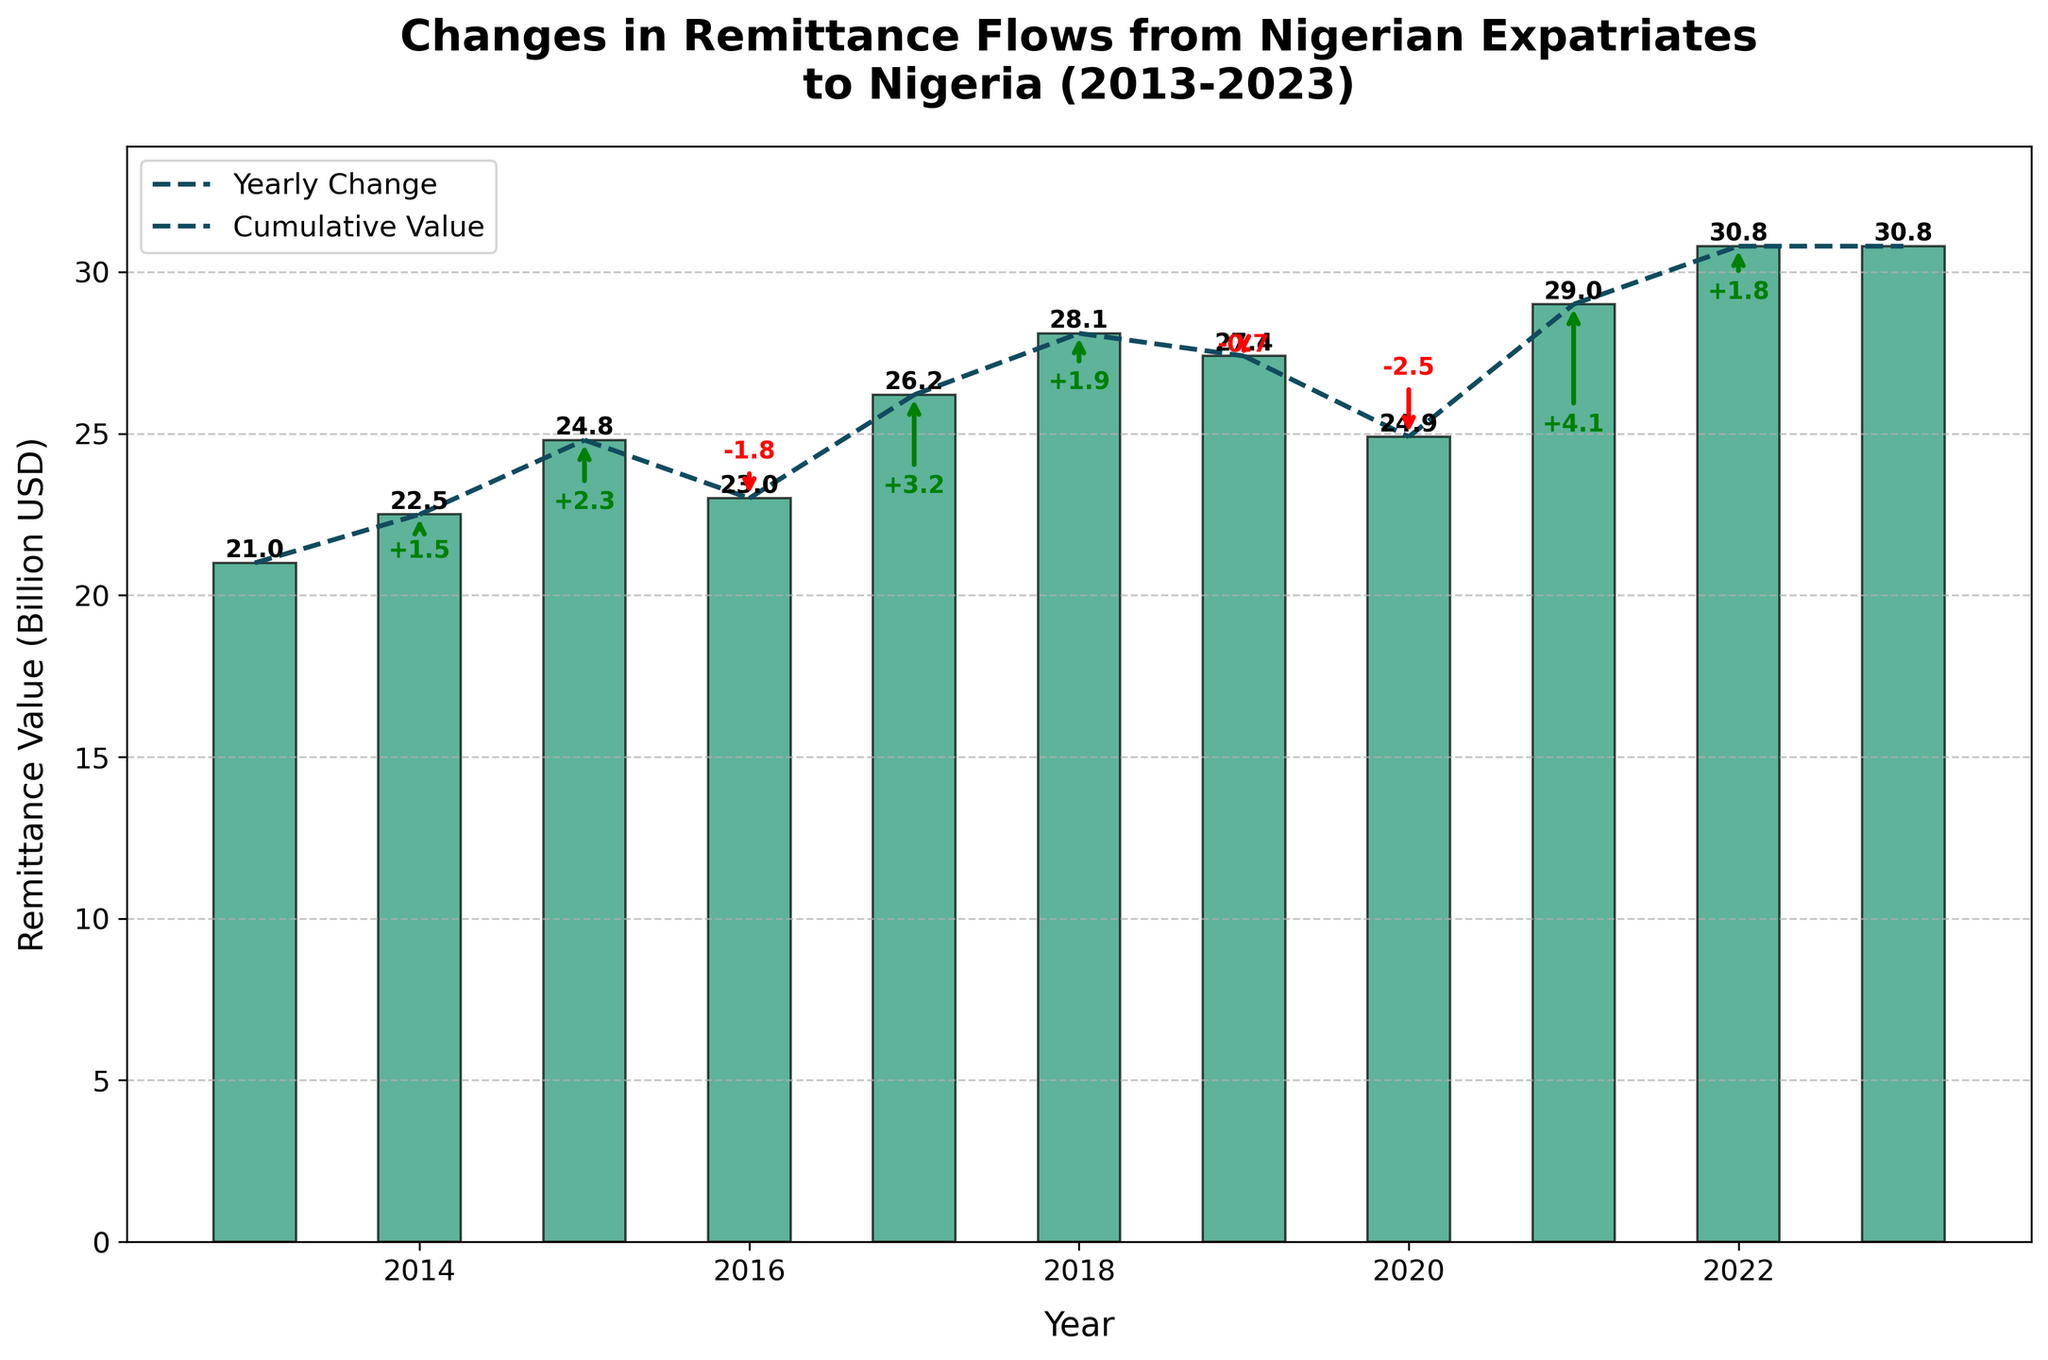How many years show an increase in remittance flows? The figure shows increases in 2014, 2015, 2017, 2018, 2021, and 2022. Count these years.
Answer: 6 What is the overall change in remittance values from 2013 to 2023? In 2013, the value starts at 21.0 billion USD, and in 2023, it ends at 30.8 billion USD. The overall change is 30.8 - 21.0.
Answer: 9.8 billion USD Which year experienced the largest increase in remittance flows? From the annotations, the largest increase is +4.1 billion USD in 2021.
Answer: 2021 During which year did remittance values decrease the most? By examining the annotations, -2.5 billion USD in 2020 is the largest decrease.
Answer: 2020 What is the cumulative value of remittance flows in 2016? Starting from 21.0 in 2013, add/subtract values year by year until reaching 2016: 21.0 + 1.5 + 2.3 - 1.8.
Answer: 23.0 billion USD What is the average annual increase in remittance flows from 2014 to 2023? Identify years with an increase (2014, 2015, 2017, 2018, 2021, 2022), sum their values (1.5 + 2.3 + 3.2 + 1.9 + 4.1 + 1.8) and divide by the number of years (6). (1.5 + 2.3 + 3.2 + 1.9 + 4.1 + 1.8) / 6.
Answer: 2.47 billion USD In which year did remittance values first surpass 25 billion USD? Following the cumulative values on the plot, remittance values first surpass 25 billion USD in 2017.
Answer: 2017 What was the remittance value at the end of 2019? Follow the cumulative values up to 2019, starting at 21.0 and adding/subtracting yearly changes up to 2019: 21.0 + 1.5 + 2.3 - 1.8 + 3.2 + 1.9 - 0.7.
Answer: 27.4 billion USD By how much did remittance values decrease from 2019 to 2020? The annotations show a decrease in remittance values by -2.5 billion USD from 2019 to 2020.
Answer: 2.5 billion USD 